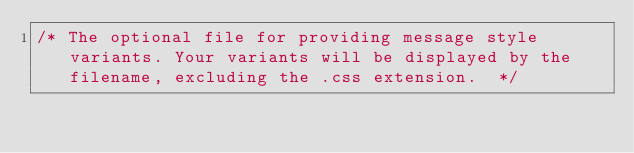Convert code to text. <code><loc_0><loc_0><loc_500><loc_500><_CSS_>/* The optional file for providing message style variants. Your variants will be displayed by the filename, excluding the .css extension.  */
</code> 